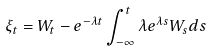Convert formula to latex. <formula><loc_0><loc_0><loc_500><loc_500>\xi _ { t } & = W _ { t } - e ^ { - \lambda t } \int _ { - \infty } ^ { t } \lambda e ^ { \lambda s } W _ { s } d s</formula> 